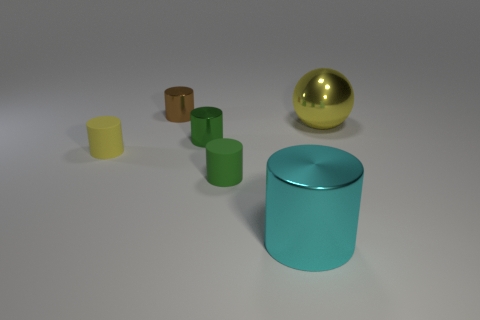Subtract all cyan cylinders. How many cylinders are left? 4 Subtract all yellow rubber cylinders. How many cylinders are left? 4 Subtract 3 cylinders. How many cylinders are left? 2 Subtract all purple cylinders. Subtract all green cubes. How many cylinders are left? 5 Add 1 large metallic things. How many objects exist? 7 Subtract all spheres. How many objects are left? 5 Add 4 cyan cylinders. How many cyan cylinders are left? 5 Add 4 rubber cylinders. How many rubber cylinders exist? 6 Subtract 0 green cubes. How many objects are left? 6 Subtract all yellow objects. Subtract all rubber cylinders. How many objects are left? 2 